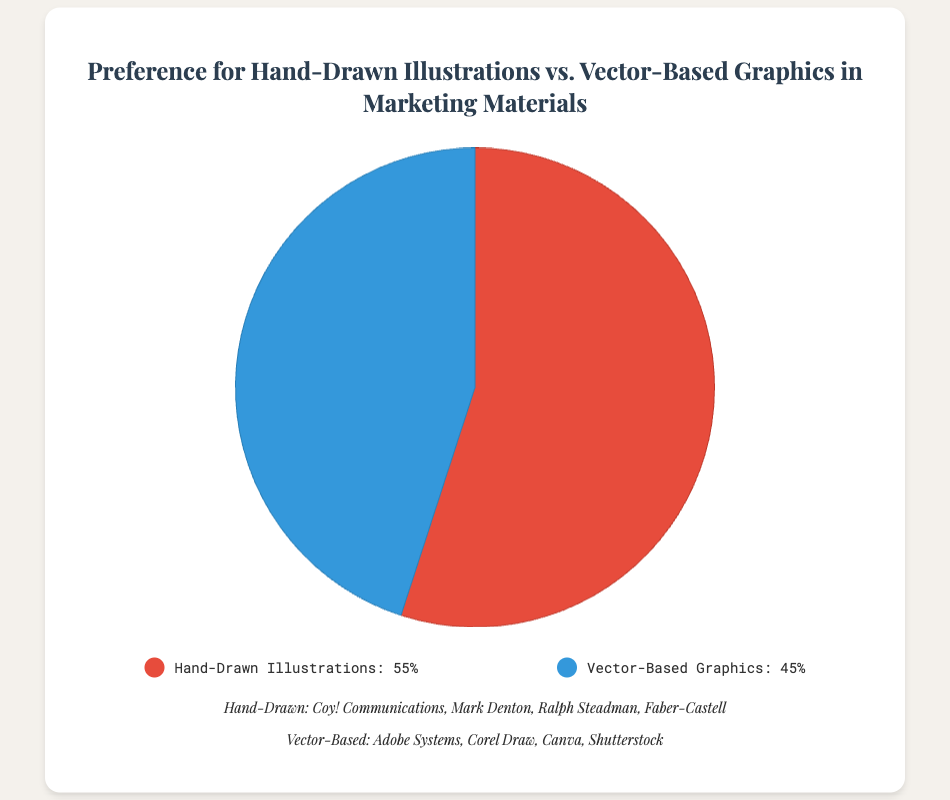What's the more popular choice between hand-drawn illustrations and vector-based graphics in marketing materials? The figure shows the percentages for both preferences: Hand-Drawn Illustrations at 55% and Vector-Based Graphics at 45%. Since 55% is greater than 45%, hand-drawn illustrations are the more popular choice.
Answer: Hand-drawn illustrations How much of a percentage difference is there between the preference for hand-drawn illustrations and vector-based graphics? The figure lists Hand-Drawn Illustrations at 55% and Vector-Based Graphics at 45%. To find the difference, subtract 45% from 55%. The difference is 10%.
Answer: 10% What percentage of people prefer vector-based graphics in marketing materials? The figure clearly shows the percentage for Vector-Based Graphics, which is labeled as 45%.
Answer: 45% If 200 people were surveyed, how many would prefer hand-drawn illustrations? We know 55% of people prefer hand-drawn illustrations. To find the number of people, we'll calculate 55% of 200. This is (55/100) * 200 = 110 people.
Answer: 110 Between hand-drawn illustrations and vector-based graphics, which preference is indicated by the red color in the pie chart? The legend in the figure shows that Hand-Drawn Illustrations are represented by the red color.
Answer: Hand-drawn illustrations Which entities are associated with the preference for vector-based graphics? The figure lists real-world entity examples under "Vector-Based Graphics," including Adobe Systems, Corel Draw, Canva, and Shutterstock.
Answer: Adobe Systems, Corel Draw, Canva, Shutterstock What is the sum of the percentages of the two preferences shown in the figure? The percentages for Hand-Drawn Illustrations and Vector-Based Graphics are 55% and 45%, respectively. Adding them gives a sum of 55 + 45 = 100%
Answer: 100% Given that vector-based graphics are less preferred, by what percentage are they less preferred than hand-drawn illustrations? The percentage for Vector-Based Graphics is 45% and for Hand-Drawn Illustrations is 55%. To find how much less preferred vector-based graphics are, subtract 45% from 55%. They are 10% less preferred.
Answer: 10% What color is used to represent the preference for vector-based graphics in the pie chart? The legend indicates that the color blue is used to represent Vector-Based Graphics in the pie chart.
Answer: Blue 